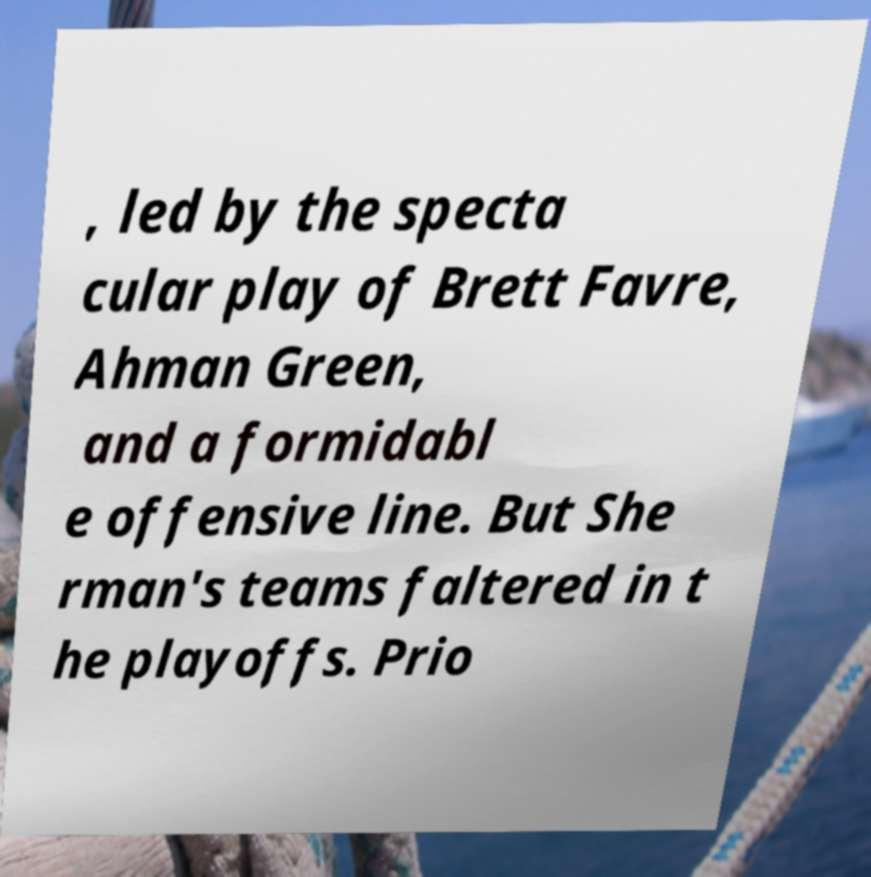Please identify and transcribe the text found in this image. , led by the specta cular play of Brett Favre, Ahman Green, and a formidabl e offensive line. But She rman's teams faltered in t he playoffs. Prio 